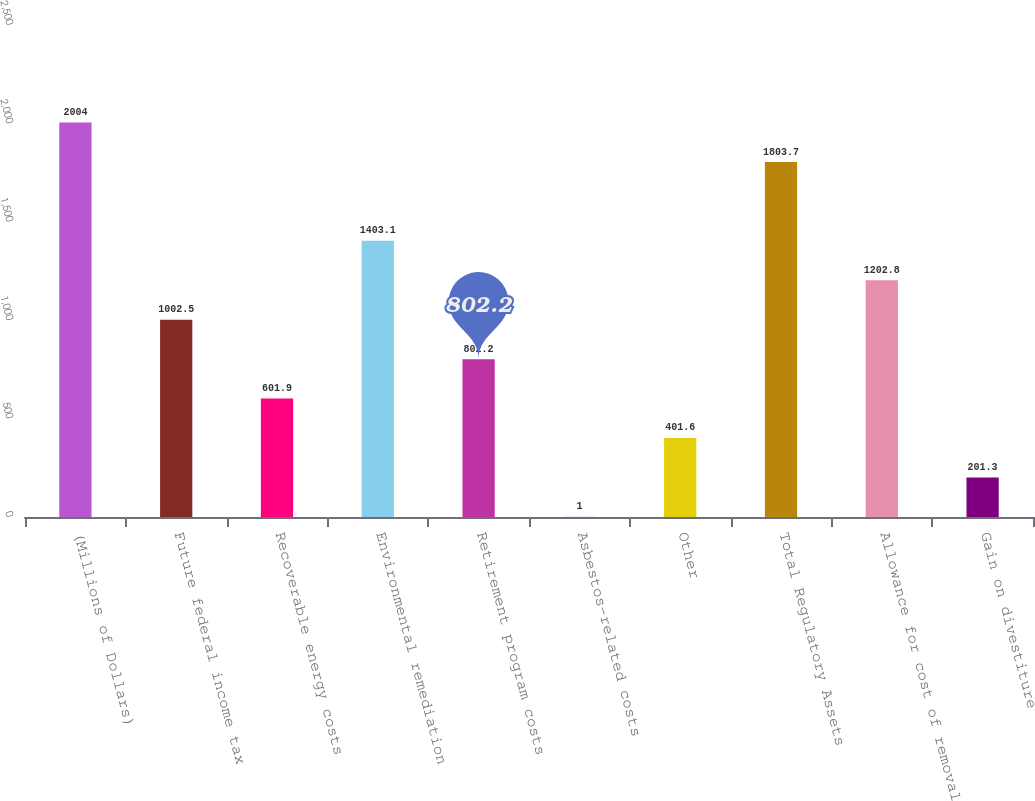Convert chart. <chart><loc_0><loc_0><loc_500><loc_500><bar_chart><fcel>(Millions of Dollars)<fcel>Future federal income tax<fcel>Recoverable energy costs<fcel>Environmental remediation<fcel>Retirement program costs<fcel>Asbestos-related costs<fcel>Other<fcel>Total Regulatory Assets<fcel>Allowance for cost of removal<fcel>Gain on divestiture<nl><fcel>2004<fcel>1002.5<fcel>601.9<fcel>1403.1<fcel>802.2<fcel>1<fcel>401.6<fcel>1803.7<fcel>1202.8<fcel>201.3<nl></chart> 